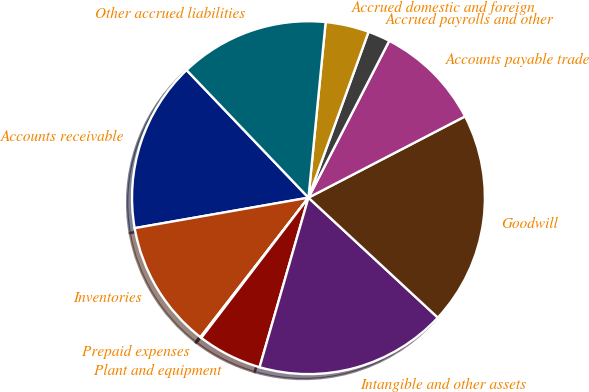<chart> <loc_0><loc_0><loc_500><loc_500><pie_chart><fcel>Accounts receivable<fcel>Inventories<fcel>Prepaid expenses<fcel>Plant and equipment<fcel>Intangible and other assets<fcel>Goodwill<fcel>Accounts payable trade<fcel>Accrued payrolls and other<fcel>Accrued domestic and foreign<fcel>Other accrued liabilities<nl><fcel>15.63%<fcel>11.75%<fcel>0.1%<fcel>5.92%<fcel>17.57%<fcel>19.52%<fcel>9.81%<fcel>2.04%<fcel>3.98%<fcel>13.69%<nl></chart> 